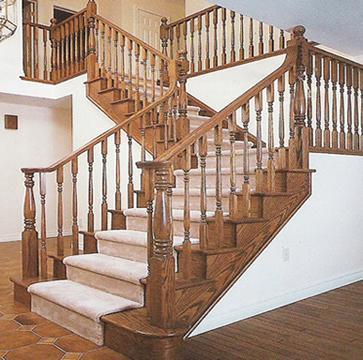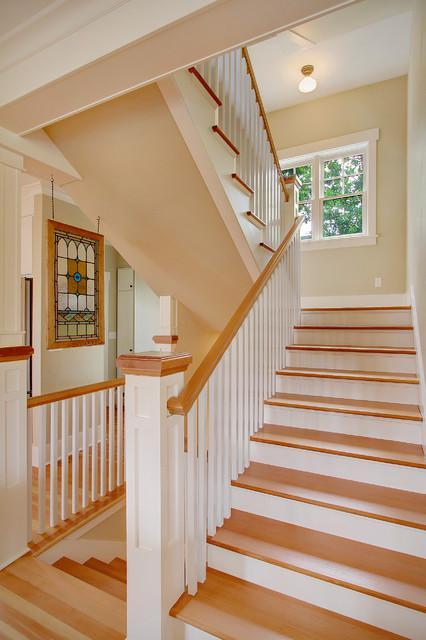The first image is the image on the left, the second image is the image on the right. Assess this claim about the two images: "The left image shows a staircase with a closed-in bottom and the edges of the stairs visible from the side, and the staircase ascends to the right, then turns leftward.". Correct or not? Answer yes or no. Yes. The first image is the image on the left, the second image is the image on the right. Evaluate the accuracy of this statement regarding the images: "In at least one image there is  white and light brown stair with a light brown rail and painted white poles.". Is it true? Answer yes or no. Yes. 